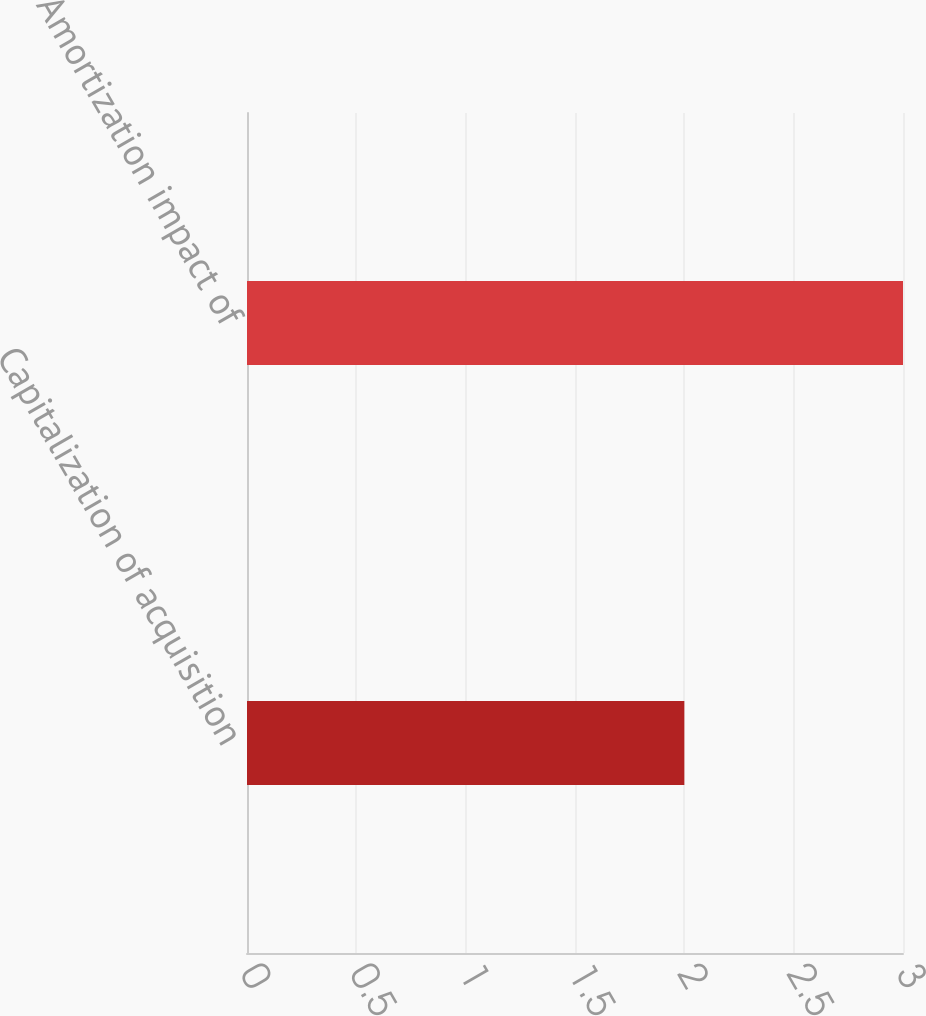Convert chart. <chart><loc_0><loc_0><loc_500><loc_500><bar_chart><fcel>Capitalization of acquisition<fcel>Amortization impact of<nl><fcel>2<fcel>3<nl></chart> 